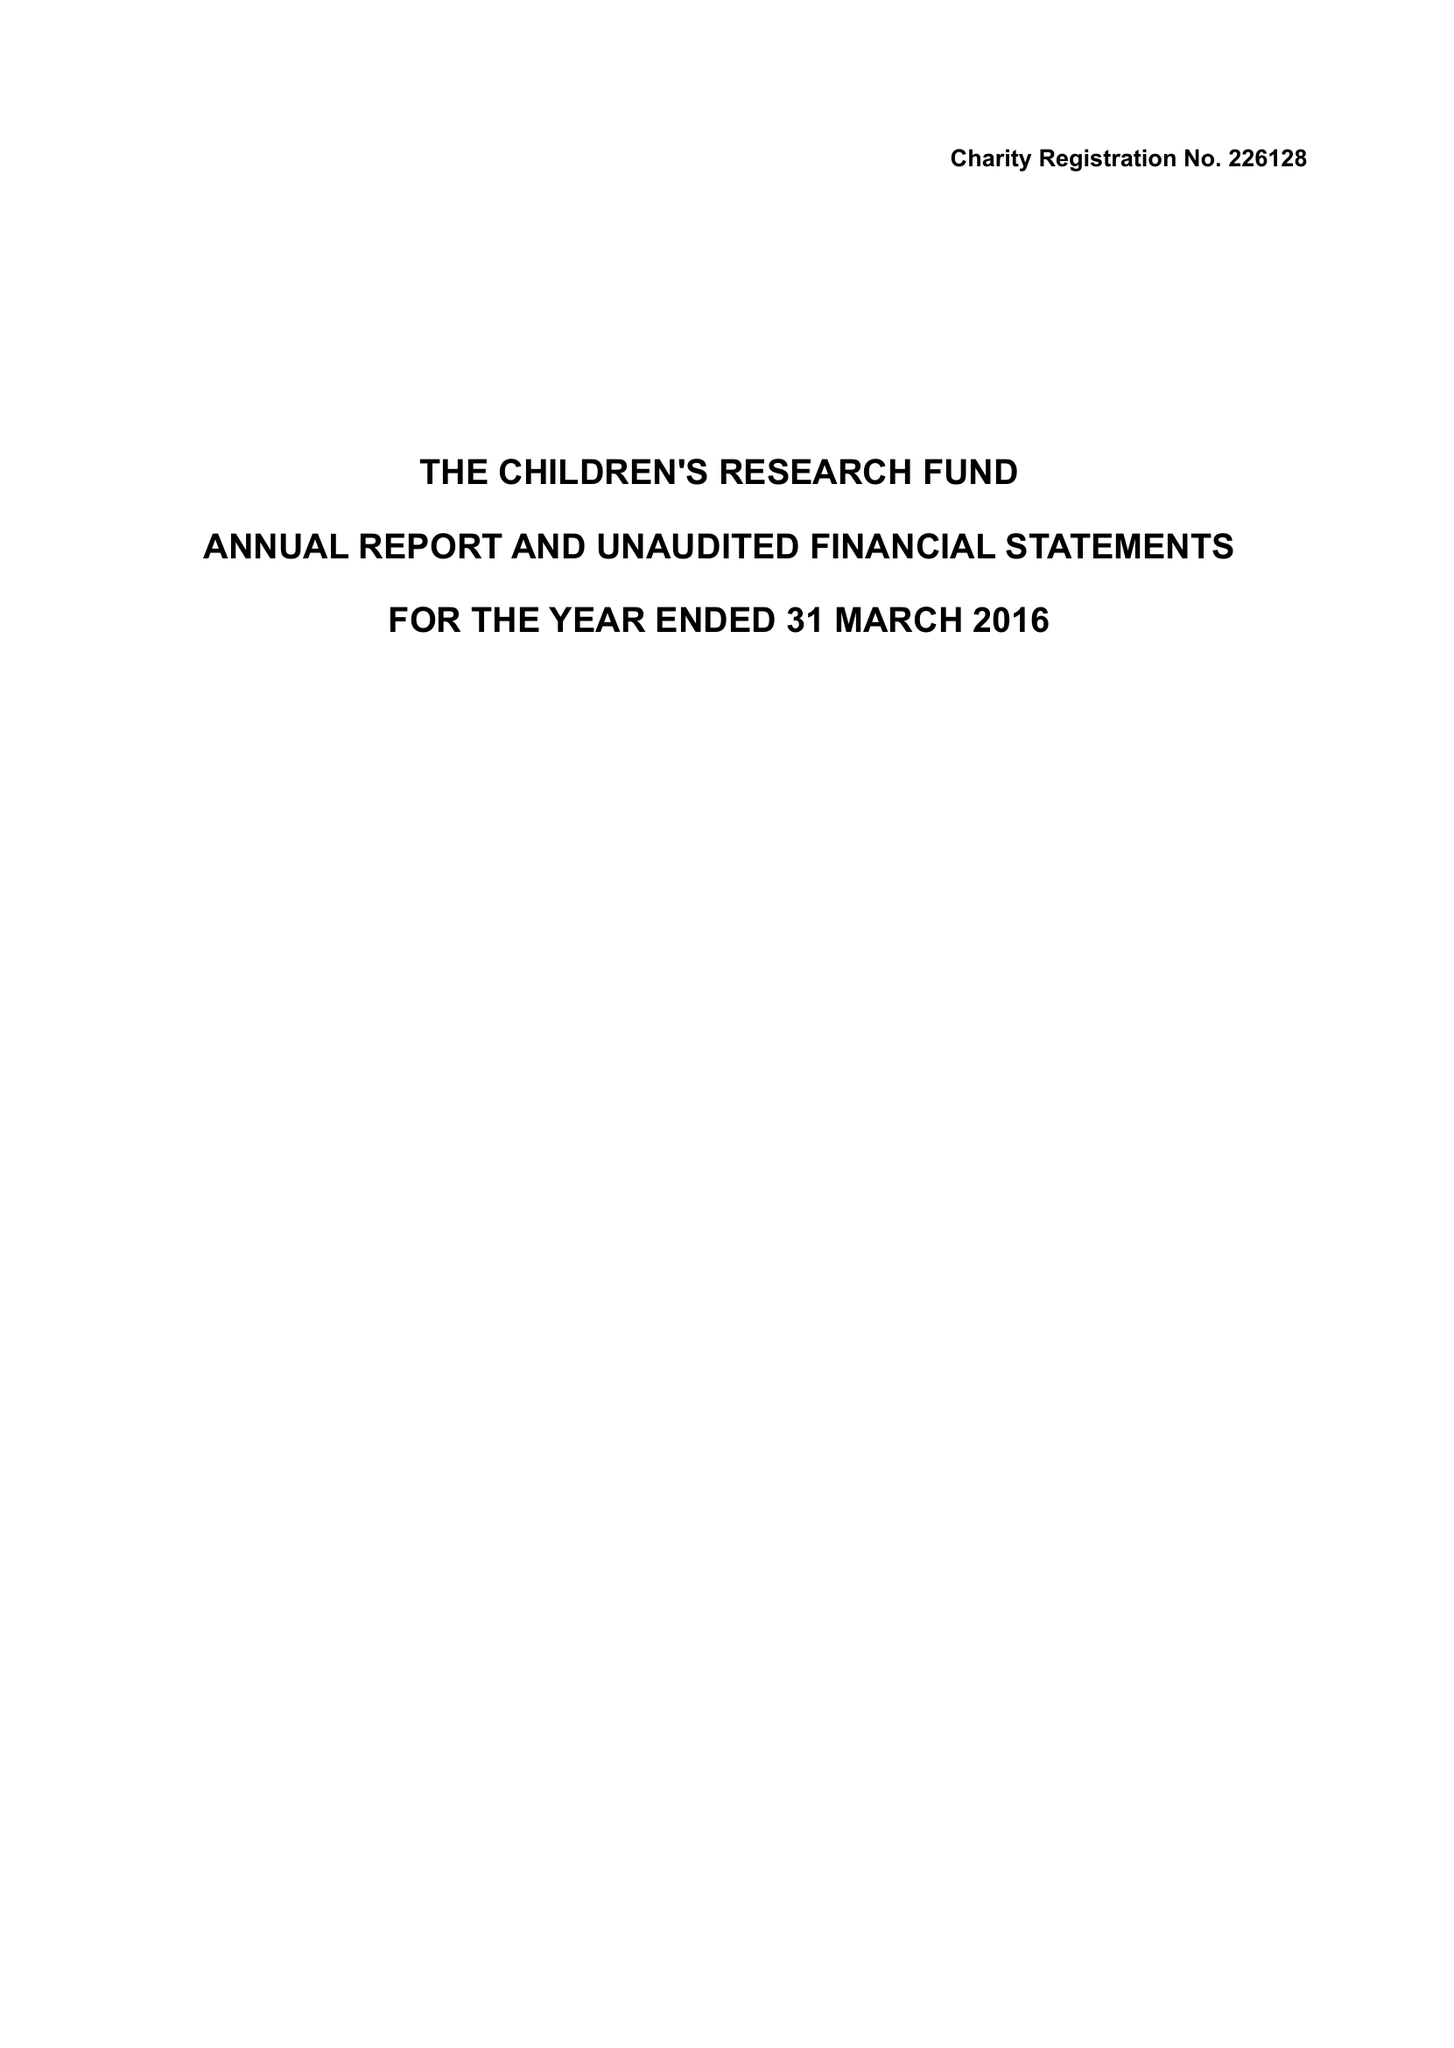What is the value for the report_date?
Answer the question using a single word or phrase. 2016-03-31 